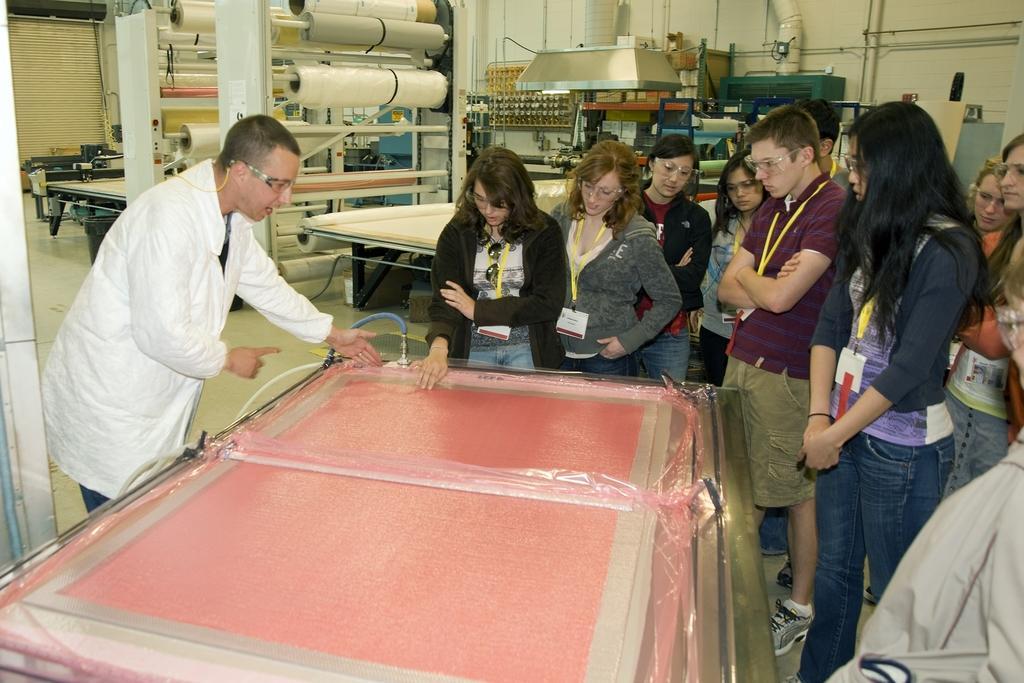Can you describe this image briefly? In this image there are people standing in front of the table. Behind them there are few objects. At the bottom of the image there is a floor. In the background of the image there is a shutter. 